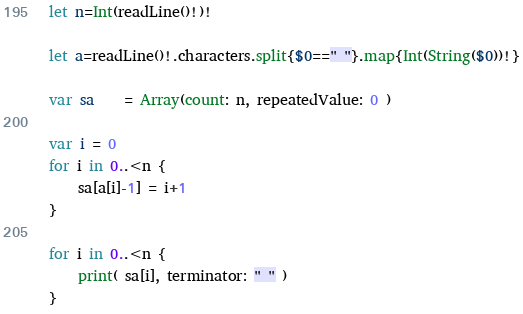Convert code to text. <code><loc_0><loc_0><loc_500><loc_500><_Swift_>let n=Int(readLine()!)!

let a=readLine()!.characters.split{$0==" "}.map{Int(String($0))!}

var sa 	= Array(count: n, repeatedValue: 0 )

var i = 0
for i in 0..<n {
	sa[a[i]-1] = i+1
}

for i in 0..<n {
	print( sa[i], terminator: " " )
}</code> 